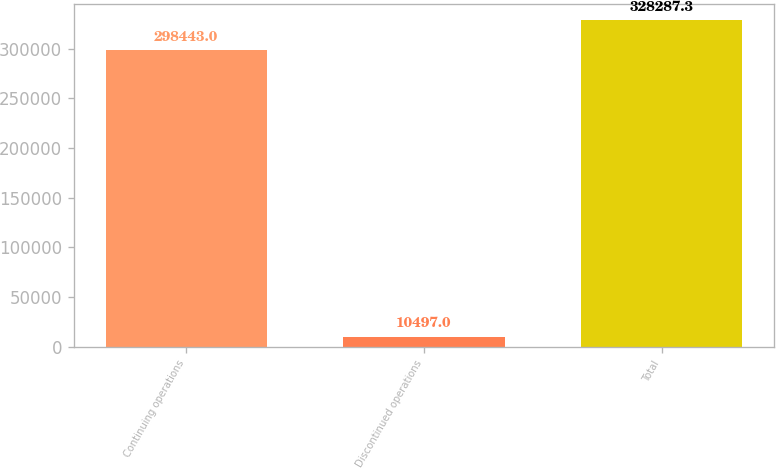Convert chart to OTSL. <chart><loc_0><loc_0><loc_500><loc_500><bar_chart><fcel>Continuing operations<fcel>Discontinued operations<fcel>Total<nl><fcel>298443<fcel>10497<fcel>328287<nl></chart> 